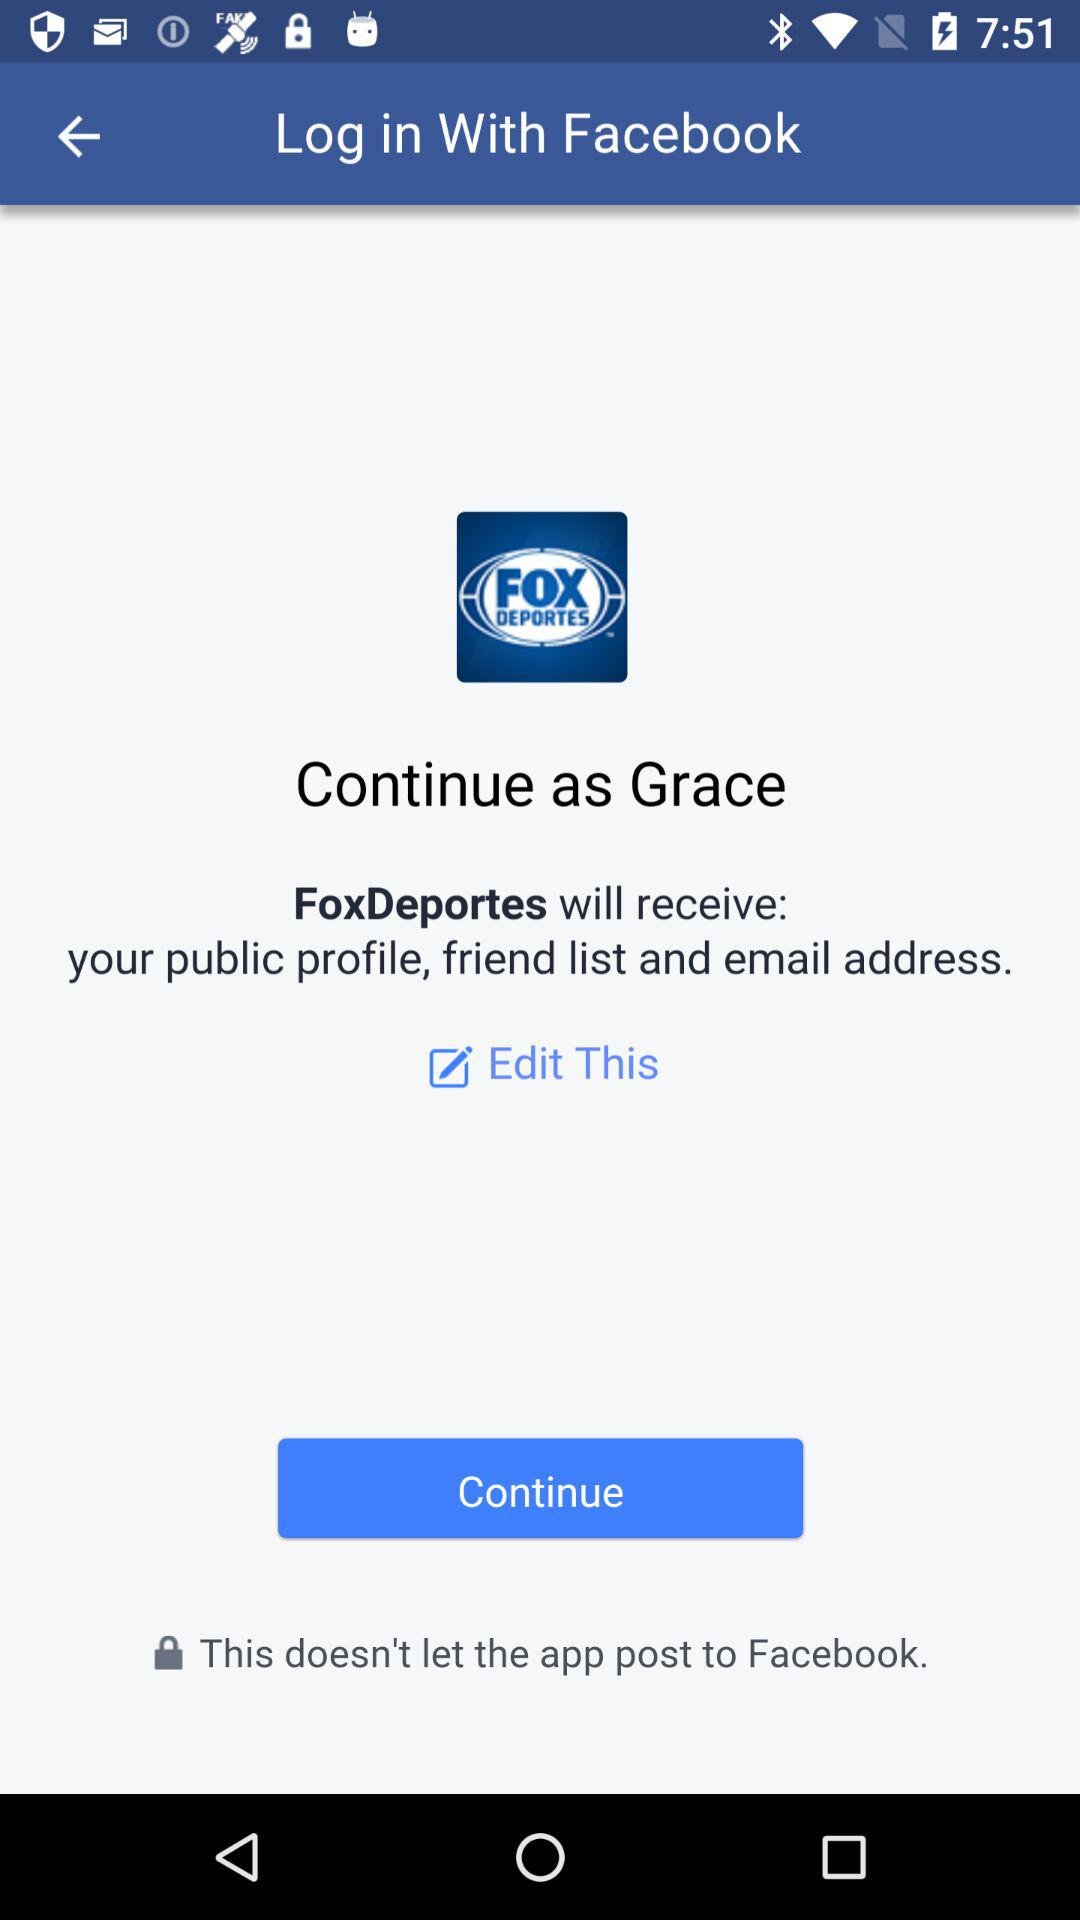Which information will "FoxDeportes" receive? "FoxDeportes" will receive the public profile, friend list and email address. 